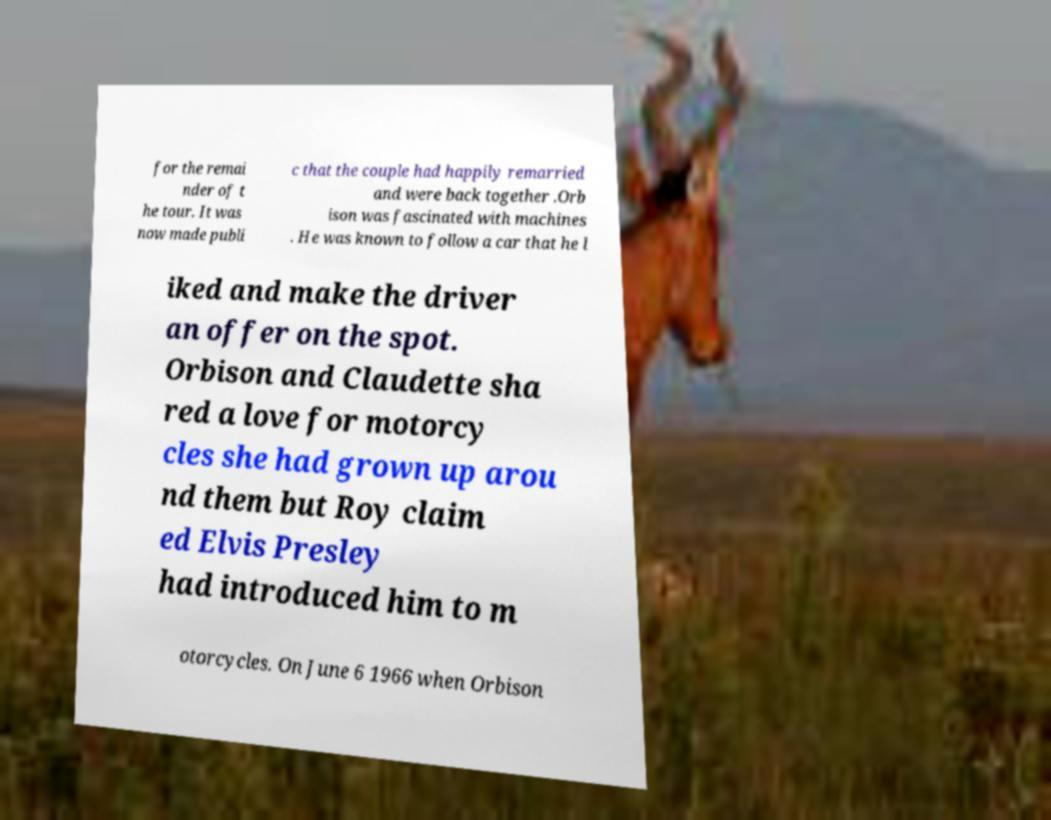For documentation purposes, I need the text within this image transcribed. Could you provide that? for the remai nder of t he tour. It was now made publi c that the couple had happily remarried and were back together .Orb ison was fascinated with machines . He was known to follow a car that he l iked and make the driver an offer on the spot. Orbison and Claudette sha red a love for motorcy cles she had grown up arou nd them but Roy claim ed Elvis Presley had introduced him to m otorcycles. On June 6 1966 when Orbison 